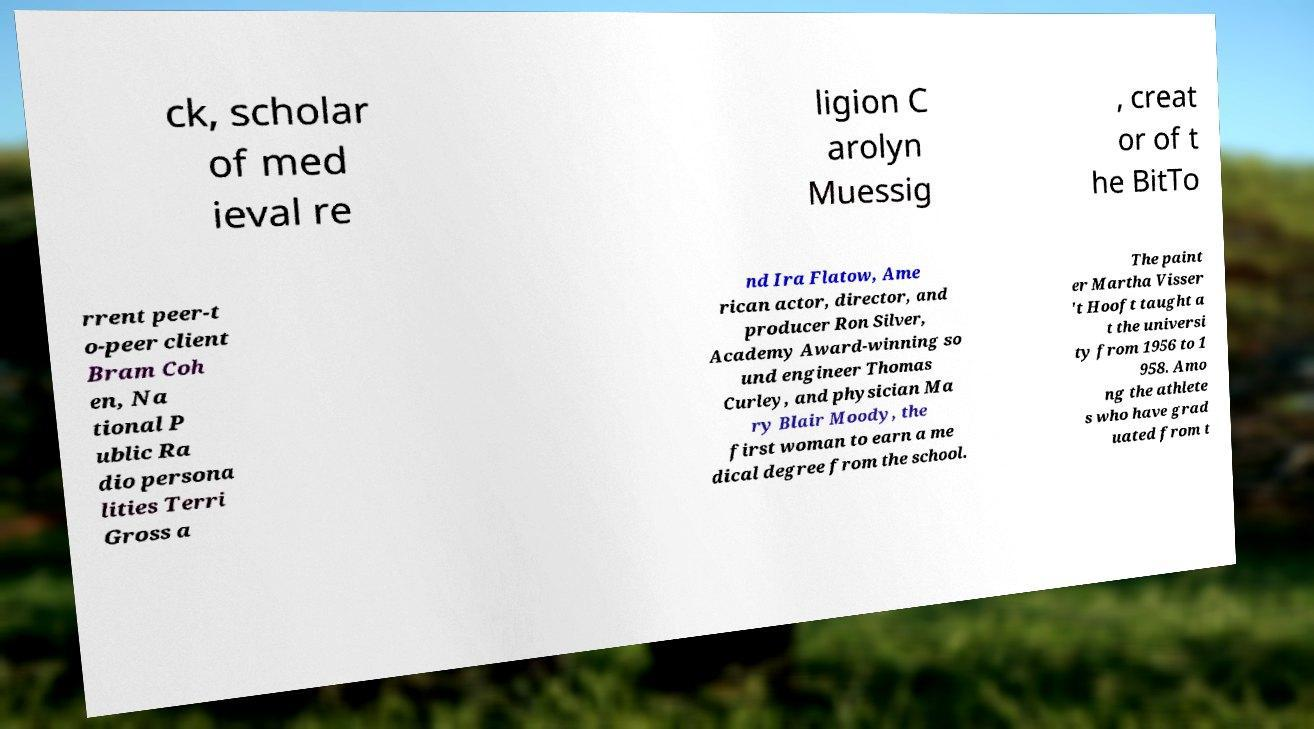Could you extract and type out the text from this image? ck, scholar of med ieval re ligion C arolyn Muessig , creat or of t he BitTo rrent peer-t o-peer client Bram Coh en, Na tional P ublic Ra dio persona lities Terri Gross a nd Ira Flatow, Ame rican actor, director, and producer Ron Silver, Academy Award-winning so und engineer Thomas Curley, and physician Ma ry Blair Moody, the first woman to earn a me dical degree from the school. The paint er Martha Visser 't Hooft taught a t the universi ty from 1956 to 1 958. Amo ng the athlete s who have grad uated from t 